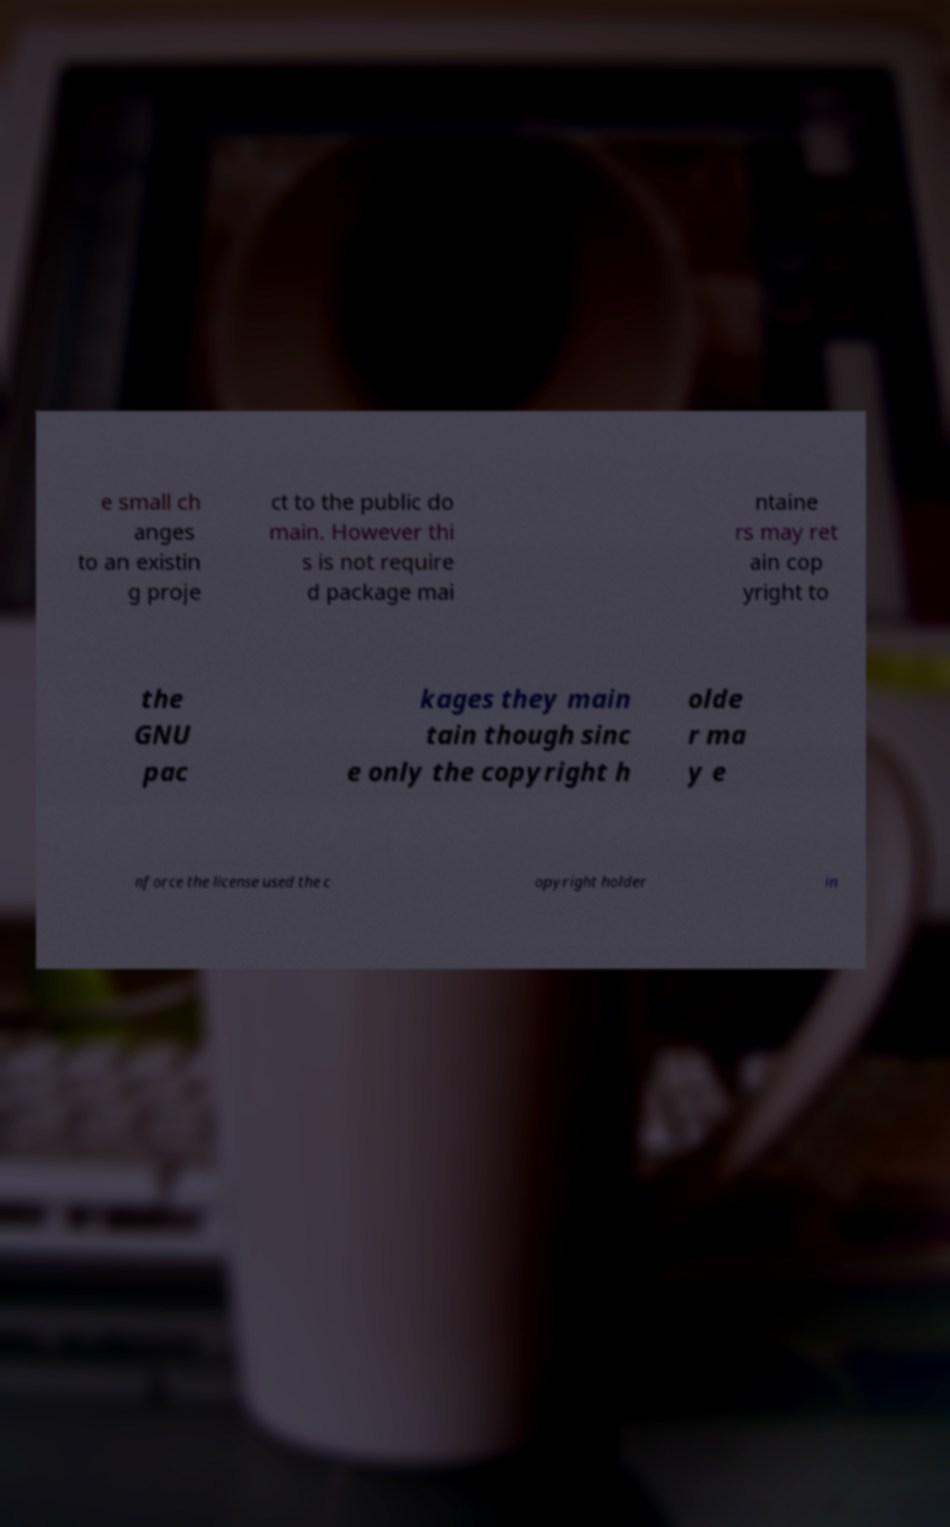Can you accurately transcribe the text from the provided image for me? e small ch anges to an existin g proje ct to the public do main. However thi s is not require d package mai ntaine rs may ret ain cop yright to the GNU pac kages they main tain though sinc e only the copyright h olde r ma y e nforce the license used the c opyright holder in 